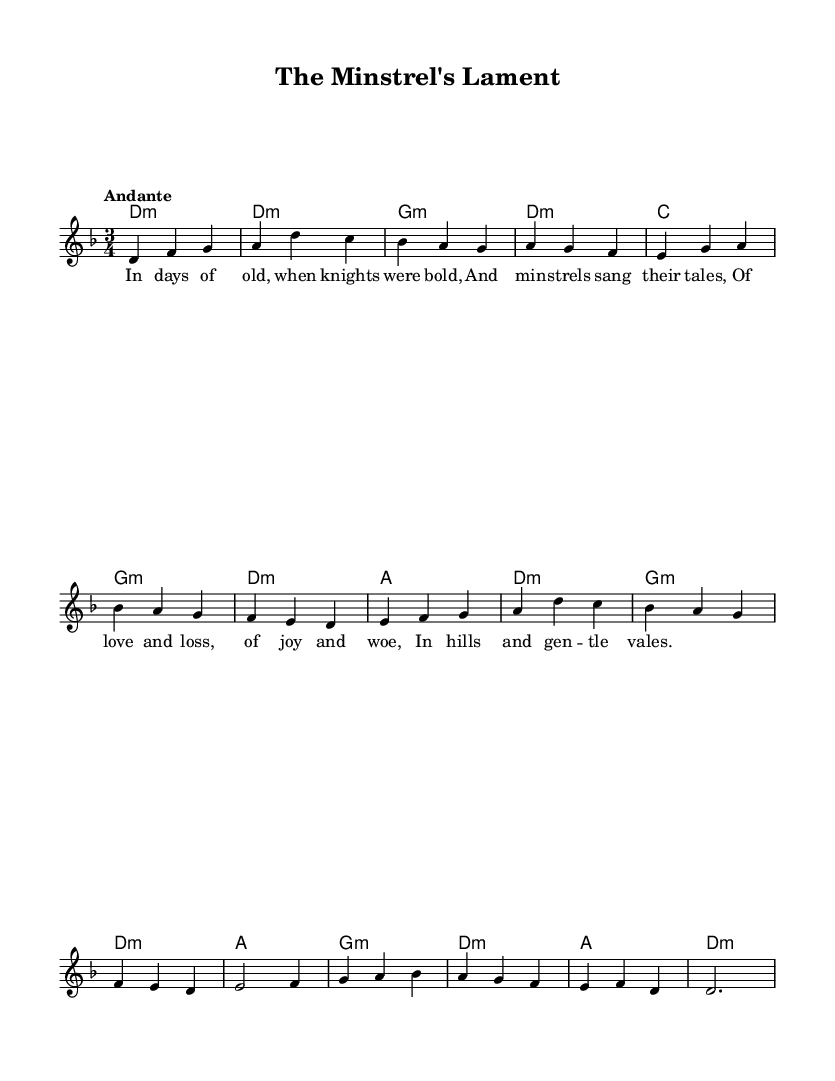What is the key signature of this music? The key signature shown is one flat, indicating D minor. D minor contains one flat (B♭).
Answer: D minor What is the time signature of this music? The time signature is indicated by the numbers at the beginning of the piece as 3/4, which means there are three beats per measure and the quarter note gets one beat.
Answer: 3/4 What is the tempo marking of this music? The tempo marking "Andante" suggests a moderate walking pace, typically around 76-108 beats per minute. This marking is explicitly indicated at the beginning of the sheet music.
Answer: Andante How many measures are in the melody? Counting the measures indicated by vertical lines, there are 8 measures in the melody. Each segment of notes separated by a bar line constitutes one measure.
Answer: 8 What type of chords are predominantly used in the harmonies? The chords shown are predominantly minor chords, as indicated by the suffix "m" next to the chord names, representing the minor tonality throughout the piece.
Answer: Minor What themes are conveyed in the lyrics of the song? The lyrics reflect themes of nostalgia and storytelling, emphasizing knights and minstrel tales of love, loss, joy, and woe in a pastoral setting, which is common in folk traditions.
Answer: Nostalgia and storytelling What is the final note of the melody? The last note in the melody measure is a D, which is on the second line of the staff, marking this note at the end of the piece.
Answer: D 